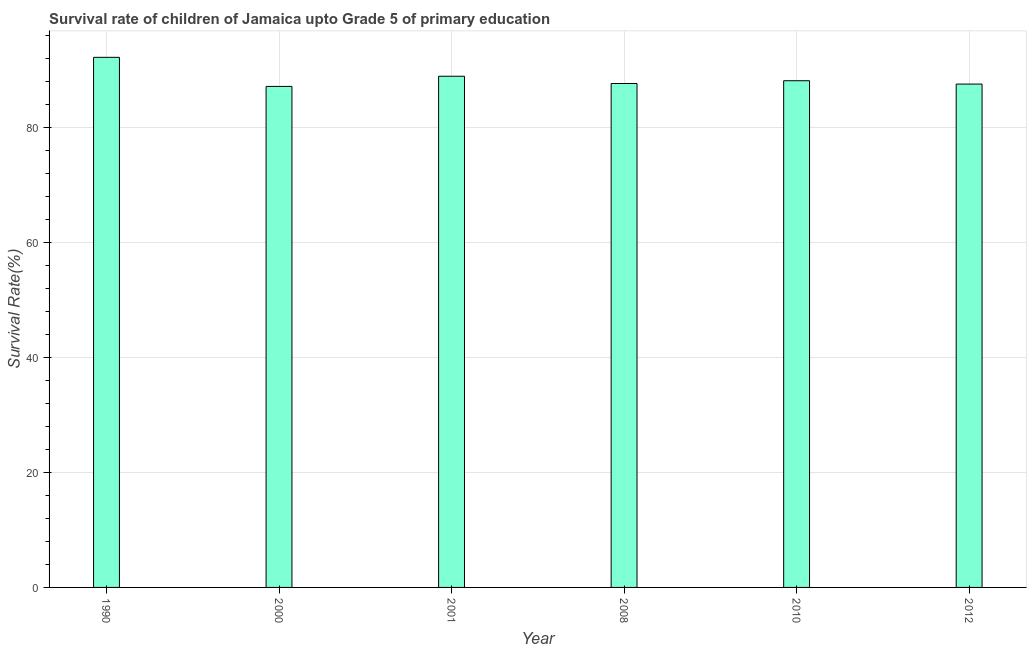Does the graph contain any zero values?
Ensure brevity in your answer.  No. Does the graph contain grids?
Keep it short and to the point. Yes. What is the title of the graph?
Your answer should be very brief. Survival rate of children of Jamaica upto Grade 5 of primary education. What is the label or title of the X-axis?
Provide a succinct answer. Year. What is the label or title of the Y-axis?
Offer a terse response. Survival Rate(%). What is the survival rate in 1990?
Ensure brevity in your answer.  92.17. Across all years, what is the maximum survival rate?
Your answer should be very brief. 92.17. Across all years, what is the minimum survival rate?
Your response must be concise. 87.12. What is the sum of the survival rate?
Make the answer very short. 531.42. What is the difference between the survival rate in 2000 and 2008?
Provide a succinct answer. -0.51. What is the average survival rate per year?
Give a very brief answer. 88.57. What is the median survival rate?
Your answer should be compact. 87.86. Do a majority of the years between 2008 and 2000 (inclusive) have survival rate greater than 64 %?
Provide a short and direct response. Yes. Is the difference between the survival rate in 2000 and 2012 greater than the difference between any two years?
Your answer should be very brief. No. What is the difference between the highest and the second highest survival rate?
Provide a short and direct response. 3.29. Is the sum of the survival rate in 2000 and 2001 greater than the maximum survival rate across all years?
Offer a terse response. Yes. What is the difference between the highest and the lowest survival rate?
Provide a short and direct response. 5.06. In how many years, is the survival rate greater than the average survival rate taken over all years?
Offer a very short reply. 2. How many bars are there?
Provide a short and direct response. 6. Are all the bars in the graph horizontal?
Your response must be concise. No. How many years are there in the graph?
Give a very brief answer. 6. What is the difference between two consecutive major ticks on the Y-axis?
Keep it short and to the point. 20. Are the values on the major ticks of Y-axis written in scientific E-notation?
Offer a terse response. No. What is the Survival Rate(%) of 1990?
Offer a very short reply. 92.17. What is the Survival Rate(%) of 2000?
Make the answer very short. 87.12. What is the Survival Rate(%) of 2001?
Provide a short and direct response. 88.88. What is the Survival Rate(%) of 2008?
Provide a succinct answer. 87.62. What is the Survival Rate(%) of 2010?
Give a very brief answer. 88.1. What is the Survival Rate(%) in 2012?
Your response must be concise. 87.52. What is the difference between the Survival Rate(%) in 1990 and 2000?
Ensure brevity in your answer.  5.06. What is the difference between the Survival Rate(%) in 1990 and 2001?
Give a very brief answer. 3.29. What is the difference between the Survival Rate(%) in 1990 and 2008?
Offer a terse response. 4.55. What is the difference between the Survival Rate(%) in 1990 and 2010?
Your response must be concise. 4.07. What is the difference between the Survival Rate(%) in 1990 and 2012?
Offer a terse response. 4.65. What is the difference between the Survival Rate(%) in 2000 and 2001?
Give a very brief answer. -1.77. What is the difference between the Survival Rate(%) in 2000 and 2008?
Offer a very short reply. -0.51. What is the difference between the Survival Rate(%) in 2000 and 2010?
Ensure brevity in your answer.  -0.99. What is the difference between the Survival Rate(%) in 2000 and 2012?
Provide a succinct answer. -0.41. What is the difference between the Survival Rate(%) in 2001 and 2008?
Provide a short and direct response. 1.26. What is the difference between the Survival Rate(%) in 2001 and 2010?
Offer a terse response. 0.78. What is the difference between the Survival Rate(%) in 2001 and 2012?
Your answer should be very brief. 1.36. What is the difference between the Survival Rate(%) in 2008 and 2010?
Your answer should be very brief. -0.48. What is the difference between the Survival Rate(%) in 2008 and 2012?
Offer a very short reply. 0.1. What is the difference between the Survival Rate(%) in 2010 and 2012?
Ensure brevity in your answer.  0.58. What is the ratio of the Survival Rate(%) in 1990 to that in 2000?
Keep it short and to the point. 1.06. What is the ratio of the Survival Rate(%) in 1990 to that in 2008?
Offer a very short reply. 1.05. What is the ratio of the Survival Rate(%) in 1990 to that in 2010?
Offer a terse response. 1.05. What is the ratio of the Survival Rate(%) in 1990 to that in 2012?
Provide a succinct answer. 1.05. What is the ratio of the Survival Rate(%) in 2000 to that in 2001?
Your answer should be compact. 0.98. What is the ratio of the Survival Rate(%) in 2000 to that in 2010?
Your response must be concise. 0.99. What is the ratio of the Survival Rate(%) in 2000 to that in 2012?
Provide a short and direct response. 0.99. What is the ratio of the Survival Rate(%) in 2001 to that in 2012?
Ensure brevity in your answer.  1.02. What is the ratio of the Survival Rate(%) in 2008 to that in 2010?
Offer a terse response. 0.99. What is the ratio of the Survival Rate(%) in 2010 to that in 2012?
Your answer should be compact. 1.01. 